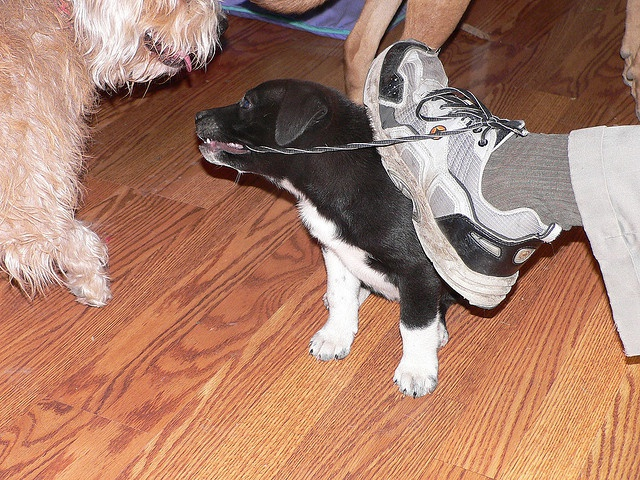Describe the objects in this image and their specific colors. I can see people in gray, lightgray, darkgray, and black tones, dog in gray, tan, lightgray, and darkgray tones, and dog in gray, black, and white tones in this image. 